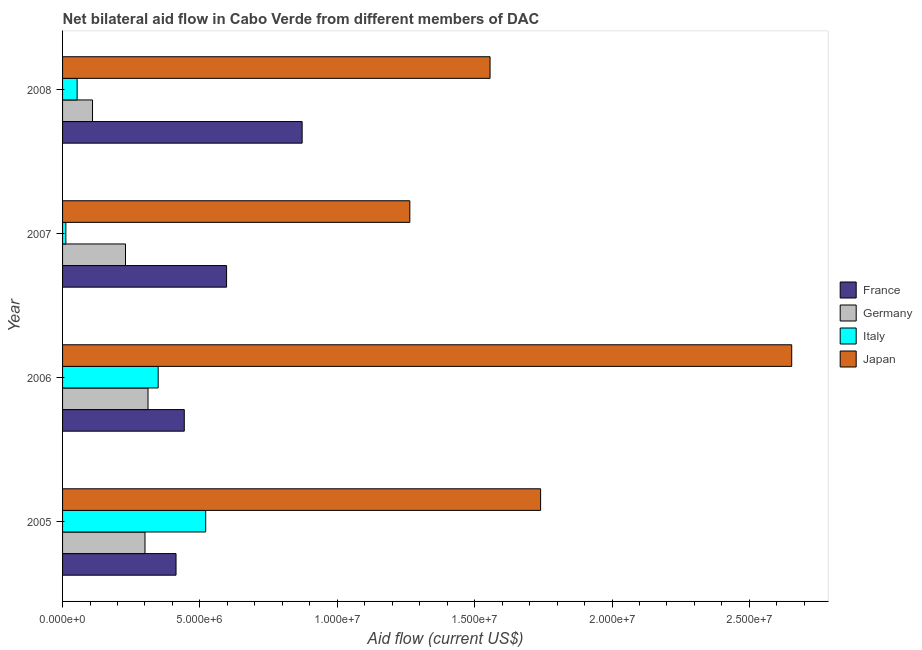Are the number of bars per tick equal to the number of legend labels?
Your answer should be compact. Yes. Are the number of bars on each tick of the Y-axis equal?
Your response must be concise. Yes. How many bars are there on the 1st tick from the top?
Your answer should be compact. 4. How many bars are there on the 3rd tick from the bottom?
Your answer should be compact. 4. What is the amount of aid given by italy in 2005?
Keep it short and to the point. 5.21e+06. Across all years, what is the maximum amount of aid given by italy?
Make the answer very short. 5.21e+06. Across all years, what is the minimum amount of aid given by japan?
Your answer should be compact. 1.26e+07. In which year was the amount of aid given by france maximum?
Provide a succinct answer. 2008. What is the total amount of aid given by italy in the graph?
Offer a very short reply. 9.34e+06. What is the difference between the amount of aid given by germany in 2005 and that in 2007?
Give a very brief answer. 7.10e+05. What is the difference between the amount of aid given by germany in 2006 and the amount of aid given by japan in 2007?
Your answer should be very brief. -9.53e+06. What is the average amount of aid given by france per year?
Provide a succinct answer. 5.81e+06. In the year 2007, what is the difference between the amount of aid given by germany and amount of aid given by france?
Your answer should be very brief. -3.68e+06. In how many years, is the amount of aid given by italy greater than 25000000 US$?
Your answer should be very brief. 0. What is the ratio of the amount of aid given by germany in 2006 to that in 2008?
Your response must be concise. 2.85. Is the amount of aid given by italy in 2006 less than that in 2007?
Your response must be concise. No. Is the difference between the amount of aid given by japan in 2006 and 2007 greater than the difference between the amount of aid given by france in 2006 and 2007?
Ensure brevity in your answer.  Yes. What is the difference between the highest and the second highest amount of aid given by germany?
Offer a terse response. 1.10e+05. What is the difference between the highest and the lowest amount of aid given by germany?
Keep it short and to the point. 2.02e+06. Is the sum of the amount of aid given by italy in 2007 and 2008 greater than the maximum amount of aid given by germany across all years?
Provide a succinct answer. No. Is it the case that in every year, the sum of the amount of aid given by france and amount of aid given by germany is greater than the amount of aid given by italy?
Offer a very short reply. Yes. How many bars are there?
Your response must be concise. 16. How many years are there in the graph?
Offer a very short reply. 4. Are the values on the major ticks of X-axis written in scientific E-notation?
Your response must be concise. Yes. How many legend labels are there?
Provide a succinct answer. 4. What is the title of the graph?
Your response must be concise. Net bilateral aid flow in Cabo Verde from different members of DAC. What is the label or title of the Y-axis?
Your answer should be very brief. Year. What is the Aid flow (current US$) in France in 2005?
Ensure brevity in your answer.  4.13e+06. What is the Aid flow (current US$) in Germany in 2005?
Provide a succinct answer. 3.00e+06. What is the Aid flow (current US$) in Italy in 2005?
Ensure brevity in your answer.  5.21e+06. What is the Aid flow (current US$) of Japan in 2005?
Ensure brevity in your answer.  1.74e+07. What is the Aid flow (current US$) in France in 2006?
Offer a terse response. 4.43e+06. What is the Aid flow (current US$) in Germany in 2006?
Your answer should be very brief. 3.11e+06. What is the Aid flow (current US$) of Italy in 2006?
Provide a short and direct response. 3.48e+06. What is the Aid flow (current US$) of Japan in 2006?
Make the answer very short. 2.65e+07. What is the Aid flow (current US$) in France in 2007?
Your answer should be very brief. 5.97e+06. What is the Aid flow (current US$) in Germany in 2007?
Keep it short and to the point. 2.29e+06. What is the Aid flow (current US$) of Italy in 2007?
Ensure brevity in your answer.  1.20e+05. What is the Aid flow (current US$) in Japan in 2007?
Offer a terse response. 1.26e+07. What is the Aid flow (current US$) in France in 2008?
Your answer should be compact. 8.72e+06. What is the Aid flow (current US$) in Germany in 2008?
Your answer should be compact. 1.09e+06. What is the Aid flow (current US$) of Italy in 2008?
Give a very brief answer. 5.30e+05. What is the Aid flow (current US$) in Japan in 2008?
Make the answer very short. 1.56e+07. Across all years, what is the maximum Aid flow (current US$) in France?
Keep it short and to the point. 8.72e+06. Across all years, what is the maximum Aid flow (current US$) in Germany?
Your response must be concise. 3.11e+06. Across all years, what is the maximum Aid flow (current US$) in Italy?
Offer a very short reply. 5.21e+06. Across all years, what is the maximum Aid flow (current US$) of Japan?
Provide a succinct answer. 2.65e+07. Across all years, what is the minimum Aid flow (current US$) of France?
Your response must be concise. 4.13e+06. Across all years, what is the minimum Aid flow (current US$) of Germany?
Offer a very short reply. 1.09e+06. Across all years, what is the minimum Aid flow (current US$) of Japan?
Your response must be concise. 1.26e+07. What is the total Aid flow (current US$) in France in the graph?
Provide a short and direct response. 2.32e+07. What is the total Aid flow (current US$) in Germany in the graph?
Offer a very short reply. 9.49e+06. What is the total Aid flow (current US$) of Italy in the graph?
Keep it short and to the point. 9.34e+06. What is the total Aid flow (current US$) of Japan in the graph?
Make the answer very short. 7.21e+07. What is the difference between the Aid flow (current US$) of Italy in 2005 and that in 2006?
Offer a terse response. 1.73e+06. What is the difference between the Aid flow (current US$) in Japan in 2005 and that in 2006?
Your response must be concise. -9.14e+06. What is the difference between the Aid flow (current US$) of France in 2005 and that in 2007?
Your response must be concise. -1.84e+06. What is the difference between the Aid flow (current US$) of Germany in 2005 and that in 2007?
Your answer should be very brief. 7.10e+05. What is the difference between the Aid flow (current US$) of Italy in 2005 and that in 2007?
Offer a terse response. 5.09e+06. What is the difference between the Aid flow (current US$) in Japan in 2005 and that in 2007?
Your response must be concise. 4.76e+06. What is the difference between the Aid flow (current US$) in France in 2005 and that in 2008?
Give a very brief answer. -4.59e+06. What is the difference between the Aid flow (current US$) in Germany in 2005 and that in 2008?
Provide a succinct answer. 1.91e+06. What is the difference between the Aid flow (current US$) of Italy in 2005 and that in 2008?
Offer a terse response. 4.68e+06. What is the difference between the Aid flow (current US$) of Japan in 2005 and that in 2008?
Make the answer very short. 1.84e+06. What is the difference between the Aid flow (current US$) of France in 2006 and that in 2007?
Provide a succinct answer. -1.54e+06. What is the difference between the Aid flow (current US$) of Germany in 2006 and that in 2007?
Your answer should be very brief. 8.20e+05. What is the difference between the Aid flow (current US$) in Italy in 2006 and that in 2007?
Give a very brief answer. 3.36e+06. What is the difference between the Aid flow (current US$) of Japan in 2006 and that in 2007?
Keep it short and to the point. 1.39e+07. What is the difference between the Aid flow (current US$) of France in 2006 and that in 2008?
Ensure brevity in your answer.  -4.29e+06. What is the difference between the Aid flow (current US$) in Germany in 2006 and that in 2008?
Offer a very short reply. 2.02e+06. What is the difference between the Aid flow (current US$) of Italy in 2006 and that in 2008?
Your response must be concise. 2.95e+06. What is the difference between the Aid flow (current US$) of Japan in 2006 and that in 2008?
Your answer should be very brief. 1.10e+07. What is the difference between the Aid flow (current US$) of France in 2007 and that in 2008?
Offer a very short reply. -2.75e+06. What is the difference between the Aid flow (current US$) of Germany in 2007 and that in 2008?
Provide a succinct answer. 1.20e+06. What is the difference between the Aid flow (current US$) of Italy in 2007 and that in 2008?
Your answer should be compact. -4.10e+05. What is the difference between the Aid flow (current US$) of Japan in 2007 and that in 2008?
Offer a very short reply. -2.92e+06. What is the difference between the Aid flow (current US$) of France in 2005 and the Aid flow (current US$) of Germany in 2006?
Offer a terse response. 1.02e+06. What is the difference between the Aid flow (current US$) in France in 2005 and the Aid flow (current US$) in Italy in 2006?
Your response must be concise. 6.50e+05. What is the difference between the Aid flow (current US$) of France in 2005 and the Aid flow (current US$) of Japan in 2006?
Provide a succinct answer. -2.24e+07. What is the difference between the Aid flow (current US$) of Germany in 2005 and the Aid flow (current US$) of Italy in 2006?
Provide a short and direct response. -4.80e+05. What is the difference between the Aid flow (current US$) in Germany in 2005 and the Aid flow (current US$) in Japan in 2006?
Ensure brevity in your answer.  -2.35e+07. What is the difference between the Aid flow (current US$) in Italy in 2005 and the Aid flow (current US$) in Japan in 2006?
Provide a short and direct response. -2.13e+07. What is the difference between the Aid flow (current US$) in France in 2005 and the Aid flow (current US$) in Germany in 2007?
Provide a succinct answer. 1.84e+06. What is the difference between the Aid flow (current US$) of France in 2005 and the Aid flow (current US$) of Italy in 2007?
Give a very brief answer. 4.01e+06. What is the difference between the Aid flow (current US$) of France in 2005 and the Aid flow (current US$) of Japan in 2007?
Offer a terse response. -8.51e+06. What is the difference between the Aid flow (current US$) in Germany in 2005 and the Aid flow (current US$) in Italy in 2007?
Your answer should be compact. 2.88e+06. What is the difference between the Aid flow (current US$) of Germany in 2005 and the Aid flow (current US$) of Japan in 2007?
Your answer should be compact. -9.64e+06. What is the difference between the Aid flow (current US$) of Italy in 2005 and the Aid flow (current US$) of Japan in 2007?
Provide a short and direct response. -7.43e+06. What is the difference between the Aid flow (current US$) of France in 2005 and the Aid flow (current US$) of Germany in 2008?
Offer a terse response. 3.04e+06. What is the difference between the Aid flow (current US$) of France in 2005 and the Aid flow (current US$) of Italy in 2008?
Offer a very short reply. 3.60e+06. What is the difference between the Aid flow (current US$) of France in 2005 and the Aid flow (current US$) of Japan in 2008?
Keep it short and to the point. -1.14e+07. What is the difference between the Aid flow (current US$) in Germany in 2005 and the Aid flow (current US$) in Italy in 2008?
Your answer should be compact. 2.47e+06. What is the difference between the Aid flow (current US$) of Germany in 2005 and the Aid flow (current US$) of Japan in 2008?
Give a very brief answer. -1.26e+07. What is the difference between the Aid flow (current US$) in Italy in 2005 and the Aid flow (current US$) in Japan in 2008?
Offer a very short reply. -1.04e+07. What is the difference between the Aid flow (current US$) of France in 2006 and the Aid flow (current US$) of Germany in 2007?
Your answer should be compact. 2.14e+06. What is the difference between the Aid flow (current US$) in France in 2006 and the Aid flow (current US$) in Italy in 2007?
Make the answer very short. 4.31e+06. What is the difference between the Aid flow (current US$) of France in 2006 and the Aid flow (current US$) of Japan in 2007?
Provide a short and direct response. -8.21e+06. What is the difference between the Aid flow (current US$) in Germany in 2006 and the Aid flow (current US$) in Italy in 2007?
Ensure brevity in your answer.  2.99e+06. What is the difference between the Aid flow (current US$) in Germany in 2006 and the Aid flow (current US$) in Japan in 2007?
Ensure brevity in your answer.  -9.53e+06. What is the difference between the Aid flow (current US$) in Italy in 2006 and the Aid flow (current US$) in Japan in 2007?
Offer a very short reply. -9.16e+06. What is the difference between the Aid flow (current US$) in France in 2006 and the Aid flow (current US$) in Germany in 2008?
Your answer should be very brief. 3.34e+06. What is the difference between the Aid flow (current US$) in France in 2006 and the Aid flow (current US$) in Italy in 2008?
Keep it short and to the point. 3.90e+06. What is the difference between the Aid flow (current US$) in France in 2006 and the Aid flow (current US$) in Japan in 2008?
Provide a succinct answer. -1.11e+07. What is the difference between the Aid flow (current US$) of Germany in 2006 and the Aid flow (current US$) of Italy in 2008?
Offer a very short reply. 2.58e+06. What is the difference between the Aid flow (current US$) of Germany in 2006 and the Aid flow (current US$) of Japan in 2008?
Make the answer very short. -1.24e+07. What is the difference between the Aid flow (current US$) in Italy in 2006 and the Aid flow (current US$) in Japan in 2008?
Ensure brevity in your answer.  -1.21e+07. What is the difference between the Aid flow (current US$) in France in 2007 and the Aid flow (current US$) in Germany in 2008?
Provide a short and direct response. 4.88e+06. What is the difference between the Aid flow (current US$) in France in 2007 and the Aid flow (current US$) in Italy in 2008?
Offer a very short reply. 5.44e+06. What is the difference between the Aid flow (current US$) in France in 2007 and the Aid flow (current US$) in Japan in 2008?
Your answer should be compact. -9.59e+06. What is the difference between the Aid flow (current US$) in Germany in 2007 and the Aid flow (current US$) in Italy in 2008?
Ensure brevity in your answer.  1.76e+06. What is the difference between the Aid flow (current US$) in Germany in 2007 and the Aid flow (current US$) in Japan in 2008?
Provide a succinct answer. -1.33e+07. What is the difference between the Aid flow (current US$) of Italy in 2007 and the Aid flow (current US$) of Japan in 2008?
Ensure brevity in your answer.  -1.54e+07. What is the average Aid flow (current US$) in France per year?
Provide a short and direct response. 5.81e+06. What is the average Aid flow (current US$) of Germany per year?
Provide a succinct answer. 2.37e+06. What is the average Aid flow (current US$) of Italy per year?
Provide a short and direct response. 2.34e+06. What is the average Aid flow (current US$) in Japan per year?
Offer a terse response. 1.80e+07. In the year 2005, what is the difference between the Aid flow (current US$) in France and Aid flow (current US$) in Germany?
Give a very brief answer. 1.13e+06. In the year 2005, what is the difference between the Aid flow (current US$) of France and Aid flow (current US$) of Italy?
Provide a succinct answer. -1.08e+06. In the year 2005, what is the difference between the Aid flow (current US$) in France and Aid flow (current US$) in Japan?
Make the answer very short. -1.33e+07. In the year 2005, what is the difference between the Aid flow (current US$) in Germany and Aid flow (current US$) in Italy?
Ensure brevity in your answer.  -2.21e+06. In the year 2005, what is the difference between the Aid flow (current US$) of Germany and Aid flow (current US$) of Japan?
Provide a succinct answer. -1.44e+07. In the year 2005, what is the difference between the Aid flow (current US$) in Italy and Aid flow (current US$) in Japan?
Ensure brevity in your answer.  -1.22e+07. In the year 2006, what is the difference between the Aid flow (current US$) of France and Aid flow (current US$) of Germany?
Keep it short and to the point. 1.32e+06. In the year 2006, what is the difference between the Aid flow (current US$) of France and Aid flow (current US$) of Italy?
Offer a very short reply. 9.50e+05. In the year 2006, what is the difference between the Aid flow (current US$) in France and Aid flow (current US$) in Japan?
Provide a short and direct response. -2.21e+07. In the year 2006, what is the difference between the Aid flow (current US$) in Germany and Aid flow (current US$) in Italy?
Your answer should be compact. -3.70e+05. In the year 2006, what is the difference between the Aid flow (current US$) in Germany and Aid flow (current US$) in Japan?
Offer a terse response. -2.34e+07. In the year 2006, what is the difference between the Aid flow (current US$) in Italy and Aid flow (current US$) in Japan?
Offer a terse response. -2.31e+07. In the year 2007, what is the difference between the Aid flow (current US$) in France and Aid flow (current US$) in Germany?
Your answer should be compact. 3.68e+06. In the year 2007, what is the difference between the Aid flow (current US$) of France and Aid flow (current US$) of Italy?
Your answer should be compact. 5.85e+06. In the year 2007, what is the difference between the Aid flow (current US$) in France and Aid flow (current US$) in Japan?
Your answer should be compact. -6.67e+06. In the year 2007, what is the difference between the Aid flow (current US$) in Germany and Aid flow (current US$) in Italy?
Give a very brief answer. 2.17e+06. In the year 2007, what is the difference between the Aid flow (current US$) in Germany and Aid flow (current US$) in Japan?
Give a very brief answer. -1.04e+07. In the year 2007, what is the difference between the Aid flow (current US$) of Italy and Aid flow (current US$) of Japan?
Keep it short and to the point. -1.25e+07. In the year 2008, what is the difference between the Aid flow (current US$) in France and Aid flow (current US$) in Germany?
Provide a short and direct response. 7.63e+06. In the year 2008, what is the difference between the Aid flow (current US$) of France and Aid flow (current US$) of Italy?
Ensure brevity in your answer.  8.19e+06. In the year 2008, what is the difference between the Aid flow (current US$) in France and Aid flow (current US$) in Japan?
Offer a terse response. -6.84e+06. In the year 2008, what is the difference between the Aid flow (current US$) in Germany and Aid flow (current US$) in Italy?
Provide a short and direct response. 5.60e+05. In the year 2008, what is the difference between the Aid flow (current US$) of Germany and Aid flow (current US$) of Japan?
Provide a short and direct response. -1.45e+07. In the year 2008, what is the difference between the Aid flow (current US$) in Italy and Aid flow (current US$) in Japan?
Make the answer very short. -1.50e+07. What is the ratio of the Aid flow (current US$) of France in 2005 to that in 2006?
Offer a very short reply. 0.93. What is the ratio of the Aid flow (current US$) in Germany in 2005 to that in 2006?
Give a very brief answer. 0.96. What is the ratio of the Aid flow (current US$) in Italy in 2005 to that in 2006?
Provide a succinct answer. 1.5. What is the ratio of the Aid flow (current US$) of Japan in 2005 to that in 2006?
Offer a very short reply. 0.66. What is the ratio of the Aid flow (current US$) in France in 2005 to that in 2007?
Ensure brevity in your answer.  0.69. What is the ratio of the Aid flow (current US$) in Germany in 2005 to that in 2007?
Your answer should be very brief. 1.31. What is the ratio of the Aid flow (current US$) in Italy in 2005 to that in 2007?
Your answer should be very brief. 43.42. What is the ratio of the Aid flow (current US$) in Japan in 2005 to that in 2007?
Your answer should be very brief. 1.38. What is the ratio of the Aid flow (current US$) in France in 2005 to that in 2008?
Offer a terse response. 0.47. What is the ratio of the Aid flow (current US$) in Germany in 2005 to that in 2008?
Give a very brief answer. 2.75. What is the ratio of the Aid flow (current US$) of Italy in 2005 to that in 2008?
Offer a very short reply. 9.83. What is the ratio of the Aid flow (current US$) in Japan in 2005 to that in 2008?
Your answer should be compact. 1.12. What is the ratio of the Aid flow (current US$) of France in 2006 to that in 2007?
Your response must be concise. 0.74. What is the ratio of the Aid flow (current US$) of Germany in 2006 to that in 2007?
Your answer should be very brief. 1.36. What is the ratio of the Aid flow (current US$) of Japan in 2006 to that in 2007?
Offer a terse response. 2.1. What is the ratio of the Aid flow (current US$) of France in 2006 to that in 2008?
Keep it short and to the point. 0.51. What is the ratio of the Aid flow (current US$) in Germany in 2006 to that in 2008?
Provide a succinct answer. 2.85. What is the ratio of the Aid flow (current US$) in Italy in 2006 to that in 2008?
Keep it short and to the point. 6.57. What is the ratio of the Aid flow (current US$) of Japan in 2006 to that in 2008?
Ensure brevity in your answer.  1.71. What is the ratio of the Aid flow (current US$) in France in 2007 to that in 2008?
Your answer should be very brief. 0.68. What is the ratio of the Aid flow (current US$) in Germany in 2007 to that in 2008?
Offer a very short reply. 2.1. What is the ratio of the Aid flow (current US$) in Italy in 2007 to that in 2008?
Your response must be concise. 0.23. What is the ratio of the Aid flow (current US$) in Japan in 2007 to that in 2008?
Offer a very short reply. 0.81. What is the difference between the highest and the second highest Aid flow (current US$) in France?
Give a very brief answer. 2.75e+06. What is the difference between the highest and the second highest Aid flow (current US$) of Germany?
Keep it short and to the point. 1.10e+05. What is the difference between the highest and the second highest Aid flow (current US$) of Italy?
Your answer should be very brief. 1.73e+06. What is the difference between the highest and the second highest Aid flow (current US$) of Japan?
Make the answer very short. 9.14e+06. What is the difference between the highest and the lowest Aid flow (current US$) in France?
Provide a short and direct response. 4.59e+06. What is the difference between the highest and the lowest Aid flow (current US$) in Germany?
Your response must be concise. 2.02e+06. What is the difference between the highest and the lowest Aid flow (current US$) in Italy?
Make the answer very short. 5.09e+06. What is the difference between the highest and the lowest Aid flow (current US$) in Japan?
Your answer should be compact. 1.39e+07. 